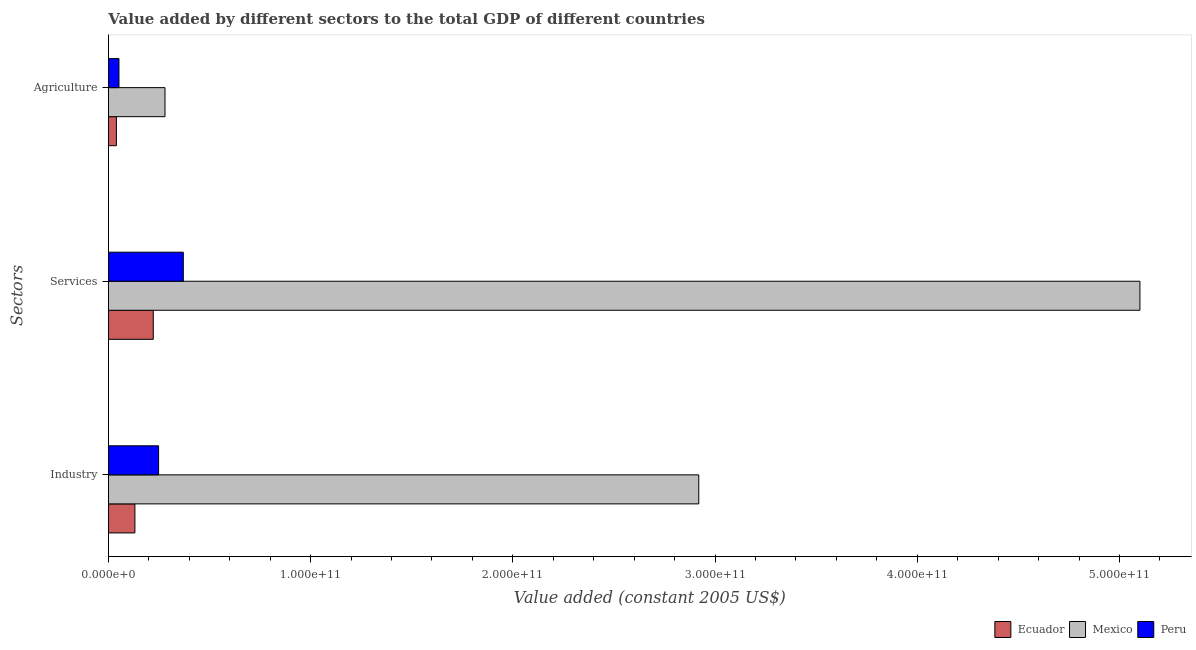How many different coloured bars are there?
Offer a very short reply. 3. How many groups of bars are there?
Your response must be concise. 3. Are the number of bars on each tick of the Y-axis equal?
Your response must be concise. Yes. What is the label of the 3rd group of bars from the top?
Provide a succinct answer. Industry. What is the value added by services in Mexico?
Offer a terse response. 5.10e+11. Across all countries, what is the maximum value added by services?
Make the answer very short. 5.10e+11. Across all countries, what is the minimum value added by agricultural sector?
Keep it short and to the point. 3.94e+09. In which country was the value added by agricultural sector maximum?
Your answer should be very brief. Mexico. In which country was the value added by services minimum?
Provide a succinct answer. Ecuador. What is the total value added by industrial sector in the graph?
Make the answer very short. 3.30e+11. What is the difference between the value added by services in Peru and that in Mexico?
Your answer should be compact. -4.73e+11. What is the difference between the value added by agricultural sector in Mexico and the value added by services in Ecuador?
Your answer should be very brief. 5.80e+09. What is the average value added by agricultural sector per country?
Give a very brief answer. 1.24e+1. What is the difference between the value added by services and value added by agricultural sector in Mexico?
Keep it short and to the point. 4.82e+11. In how many countries, is the value added by agricultural sector greater than 120000000000 US$?
Your answer should be very brief. 0. What is the ratio of the value added by industrial sector in Peru to that in Mexico?
Give a very brief answer. 0.08. Is the value added by industrial sector in Mexico less than that in Ecuador?
Provide a succinct answer. No. Is the difference between the value added by agricultural sector in Mexico and Ecuador greater than the difference between the value added by services in Mexico and Ecuador?
Offer a terse response. No. What is the difference between the highest and the second highest value added by services?
Provide a short and direct response. 4.73e+11. What is the difference between the highest and the lowest value added by industrial sector?
Give a very brief answer. 2.79e+11. Is the sum of the value added by services in Peru and Mexico greater than the maximum value added by agricultural sector across all countries?
Offer a very short reply. Yes. What does the 2nd bar from the top in Services represents?
Provide a short and direct response. Mexico. What is the difference between two consecutive major ticks on the X-axis?
Provide a succinct answer. 1.00e+11. Are the values on the major ticks of X-axis written in scientific E-notation?
Make the answer very short. Yes. Does the graph contain any zero values?
Your answer should be compact. No. How are the legend labels stacked?
Your answer should be very brief. Horizontal. What is the title of the graph?
Offer a terse response. Value added by different sectors to the total GDP of different countries. Does "Dominica" appear as one of the legend labels in the graph?
Keep it short and to the point. No. What is the label or title of the X-axis?
Keep it short and to the point. Value added (constant 2005 US$). What is the label or title of the Y-axis?
Give a very brief answer. Sectors. What is the Value added (constant 2005 US$) of Ecuador in Industry?
Provide a succinct answer. 1.31e+1. What is the Value added (constant 2005 US$) in Mexico in Industry?
Your response must be concise. 2.92e+11. What is the Value added (constant 2005 US$) of Peru in Industry?
Make the answer very short. 2.48e+1. What is the Value added (constant 2005 US$) of Ecuador in Services?
Your answer should be compact. 2.22e+1. What is the Value added (constant 2005 US$) of Mexico in Services?
Offer a terse response. 5.10e+11. What is the Value added (constant 2005 US$) of Peru in Services?
Your answer should be compact. 3.70e+1. What is the Value added (constant 2005 US$) of Ecuador in Agriculture?
Ensure brevity in your answer.  3.94e+09. What is the Value added (constant 2005 US$) of Mexico in Agriculture?
Your answer should be very brief. 2.80e+1. What is the Value added (constant 2005 US$) of Peru in Agriculture?
Provide a short and direct response. 5.21e+09. Across all Sectors, what is the maximum Value added (constant 2005 US$) in Ecuador?
Offer a very short reply. 2.22e+1. Across all Sectors, what is the maximum Value added (constant 2005 US$) in Mexico?
Offer a terse response. 5.10e+11. Across all Sectors, what is the maximum Value added (constant 2005 US$) of Peru?
Offer a very short reply. 3.70e+1. Across all Sectors, what is the minimum Value added (constant 2005 US$) of Ecuador?
Make the answer very short. 3.94e+09. Across all Sectors, what is the minimum Value added (constant 2005 US$) in Mexico?
Provide a short and direct response. 2.80e+1. Across all Sectors, what is the minimum Value added (constant 2005 US$) in Peru?
Make the answer very short. 5.21e+09. What is the total Value added (constant 2005 US$) of Ecuador in the graph?
Ensure brevity in your answer.  3.92e+1. What is the total Value added (constant 2005 US$) in Mexico in the graph?
Offer a terse response. 8.30e+11. What is the total Value added (constant 2005 US$) in Peru in the graph?
Keep it short and to the point. 6.71e+1. What is the difference between the Value added (constant 2005 US$) of Ecuador in Industry and that in Services?
Keep it short and to the point. -9.08e+09. What is the difference between the Value added (constant 2005 US$) of Mexico in Industry and that in Services?
Keep it short and to the point. -2.18e+11. What is the difference between the Value added (constant 2005 US$) of Peru in Industry and that in Services?
Offer a very short reply. -1.22e+1. What is the difference between the Value added (constant 2005 US$) in Ecuador in Industry and that in Agriculture?
Your answer should be compact. 9.16e+09. What is the difference between the Value added (constant 2005 US$) of Mexico in Industry and that in Agriculture?
Offer a terse response. 2.64e+11. What is the difference between the Value added (constant 2005 US$) of Peru in Industry and that in Agriculture?
Ensure brevity in your answer.  1.96e+1. What is the difference between the Value added (constant 2005 US$) in Ecuador in Services and that in Agriculture?
Keep it short and to the point. 1.82e+1. What is the difference between the Value added (constant 2005 US$) in Mexico in Services and that in Agriculture?
Your response must be concise. 4.82e+11. What is the difference between the Value added (constant 2005 US$) of Peru in Services and that in Agriculture?
Make the answer very short. 3.18e+1. What is the difference between the Value added (constant 2005 US$) in Ecuador in Industry and the Value added (constant 2005 US$) in Mexico in Services?
Provide a short and direct response. -4.97e+11. What is the difference between the Value added (constant 2005 US$) of Ecuador in Industry and the Value added (constant 2005 US$) of Peru in Services?
Provide a succinct answer. -2.39e+1. What is the difference between the Value added (constant 2005 US$) of Mexico in Industry and the Value added (constant 2005 US$) of Peru in Services?
Provide a short and direct response. 2.55e+11. What is the difference between the Value added (constant 2005 US$) in Ecuador in Industry and the Value added (constant 2005 US$) in Mexico in Agriculture?
Make the answer very short. -1.49e+1. What is the difference between the Value added (constant 2005 US$) in Ecuador in Industry and the Value added (constant 2005 US$) in Peru in Agriculture?
Ensure brevity in your answer.  7.88e+09. What is the difference between the Value added (constant 2005 US$) in Mexico in Industry and the Value added (constant 2005 US$) in Peru in Agriculture?
Ensure brevity in your answer.  2.87e+11. What is the difference between the Value added (constant 2005 US$) in Ecuador in Services and the Value added (constant 2005 US$) in Mexico in Agriculture?
Provide a short and direct response. -5.80e+09. What is the difference between the Value added (constant 2005 US$) of Ecuador in Services and the Value added (constant 2005 US$) of Peru in Agriculture?
Your answer should be compact. 1.70e+1. What is the difference between the Value added (constant 2005 US$) in Mexico in Services and the Value added (constant 2005 US$) in Peru in Agriculture?
Your response must be concise. 5.05e+11. What is the average Value added (constant 2005 US$) of Ecuador per Sectors?
Offer a very short reply. 1.31e+1. What is the average Value added (constant 2005 US$) in Mexico per Sectors?
Give a very brief answer. 2.77e+11. What is the average Value added (constant 2005 US$) in Peru per Sectors?
Offer a very short reply. 2.24e+1. What is the difference between the Value added (constant 2005 US$) of Ecuador and Value added (constant 2005 US$) of Mexico in Industry?
Provide a succinct answer. -2.79e+11. What is the difference between the Value added (constant 2005 US$) of Ecuador and Value added (constant 2005 US$) of Peru in Industry?
Offer a terse response. -1.17e+1. What is the difference between the Value added (constant 2005 US$) in Mexico and Value added (constant 2005 US$) in Peru in Industry?
Your answer should be very brief. 2.67e+11. What is the difference between the Value added (constant 2005 US$) in Ecuador and Value added (constant 2005 US$) in Mexico in Services?
Ensure brevity in your answer.  -4.88e+11. What is the difference between the Value added (constant 2005 US$) of Ecuador and Value added (constant 2005 US$) of Peru in Services?
Make the answer very short. -1.49e+1. What is the difference between the Value added (constant 2005 US$) in Mexico and Value added (constant 2005 US$) in Peru in Services?
Make the answer very short. 4.73e+11. What is the difference between the Value added (constant 2005 US$) of Ecuador and Value added (constant 2005 US$) of Mexico in Agriculture?
Your answer should be very brief. -2.40e+1. What is the difference between the Value added (constant 2005 US$) of Ecuador and Value added (constant 2005 US$) of Peru in Agriculture?
Your answer should be very brief. -1.27e+09. What is the difference between the Value added (constant 2005 US$) of Mexico and Value added (constant 2005 US$) of Peru in Agriculture?
Provide a short and direct response. 2.28e+1. What is the ratio of the Value added (constant 2005 US$) of Ecuador in Industry to that in Services?
Offer a very short reply. 0.59. What is the ratio of the Value added (constant 2005 US$) in Mexico in Industry to that in Services?
Your answer should be very brief. 0.57. What is the ratio of the Value added (constant 2005 US$) of Peru in Industry to that in Services?
Offer a very short reply. 0.67. What is the ratio of the Value added (constant 2005 US$) in Ecuador in Industry to that in Agriculture?
Provide a short and direct response. 3.33. What is the ratio of the Value added (constant 2005 US$) of Mexico in Industry to that in Agriculture?
Provide a succinct answer. 10.44. What is the ratio of the Value added (constant 2005 US$) of Peru in Industry to that in Agriculture?
Provide a succinct answer. 4.76. What is the ratio of the Value added (constant 2005 US$) in Ecuador in Services to that in Agriculture?
Provide a short and direct response. 5.64. What is the ratio of the Value added (constant 2005 US$) of Mexico in Services to that in Agriculture?
Your response must be concise. 18.24. What is the ratio of the Value added (constant 2005 US$) in Peru in Services to that in Agriculture?
Make the answer very short. 7.11. What is the difference between the highest and the second highest Value added (constant 2005 US$) of Ecuador?
Offer a terse response. 9.08e+09. What is the difference between the highest and the second highest Value added (constant 2005 US$) of Mexico?
Your answer should be very brief. 2.18e+11. What is the difference between the highest and the second highest Value added (constant 2005 US$) in Peru?
Keep it short and to the point. 1.22e+1. What is the difference between the highest and the lowest Value added (constant 2005 US$) in Ecuador?
Ensure brevity in your answer.  1.82e+1. What is the difference between the highest and the lowest Value added (constant 2005 US$) of Mexico?
Provide a succinct answer. 4.82e+11. What is the difference between the highest and the lowest Value added (constant 2005 US$) of Peru?
Your answer should be very brief. 3.18e+1. 